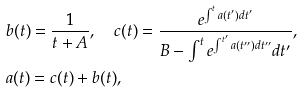Convert formula to latex. <formula><loc_0><loc_0><loc_500><loc_500>& b ( t ) = \frac { 1 } { t + A } , \quad c ( t ) = \frac { e ^ { \int ^ { t } a ( t ^ { \prime } ) d t ^ { \prime } } } { B - \int ^ { t } e ^ { \int ^ { t ^ { \prime } } a ( t ^ { \prime \prime } ) d t ^ { \prime \prime } } d t ^ { \prime } } , \\ & a ( t ) = c ( t ) + b ( t ) ,</formula> 